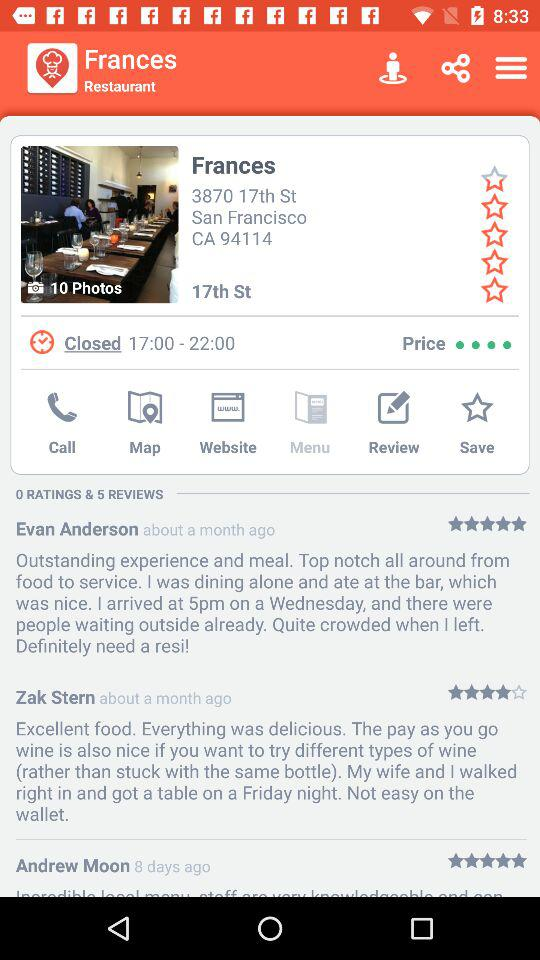What is the closing time of the restaurant? The closing time is 17:00 to 22:00. 